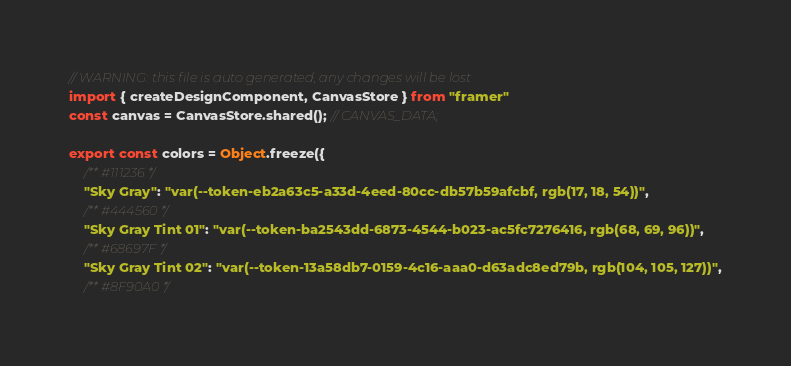Convert code to text. <code><loc_0><loc_0><loc_500><loc_500><_TypeScript_>// WARNING: this file is auto generated, any changes will be lost
import { createDesignComponent, CanvasStore } from "framer"
const canvas = CanvasStore.shared(); // CANVAS_DATA;

export const colors = Object.freeze({
    /** #111236 */
    "Sky Gray": "var(--token-eb2a63c5-a33d-4eed-80cc-db57b59afcbf, rgb(17, 18, 54))",
    /** #444560 */
    "Sky Gray Tint 01": "var(--token-ba2543dd-6873-4544-b023-ac5fc7276416, rgb(68, 69, 96))",
    /** #68697F */
    "Sky Gray Tint 02": "var(--token-13a58db7-0159-4c16-aaa0-d63adc8ed79b, rgb(104, 105, 127))",
    /** #8F90A0 */</code> 